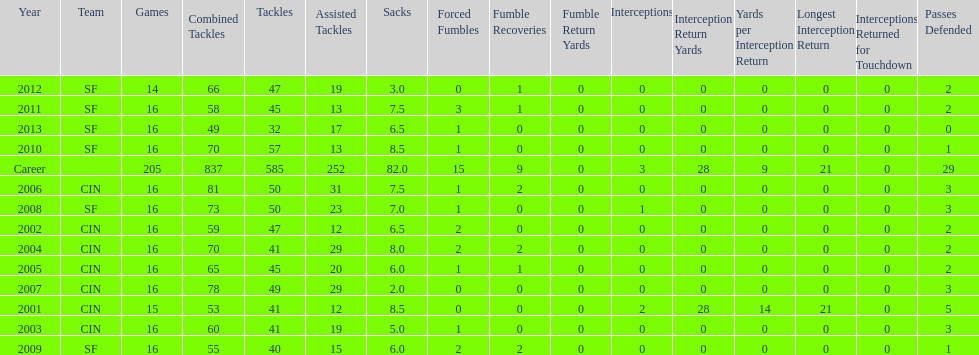What is the average number of tackles this player has had over his career? 45. 